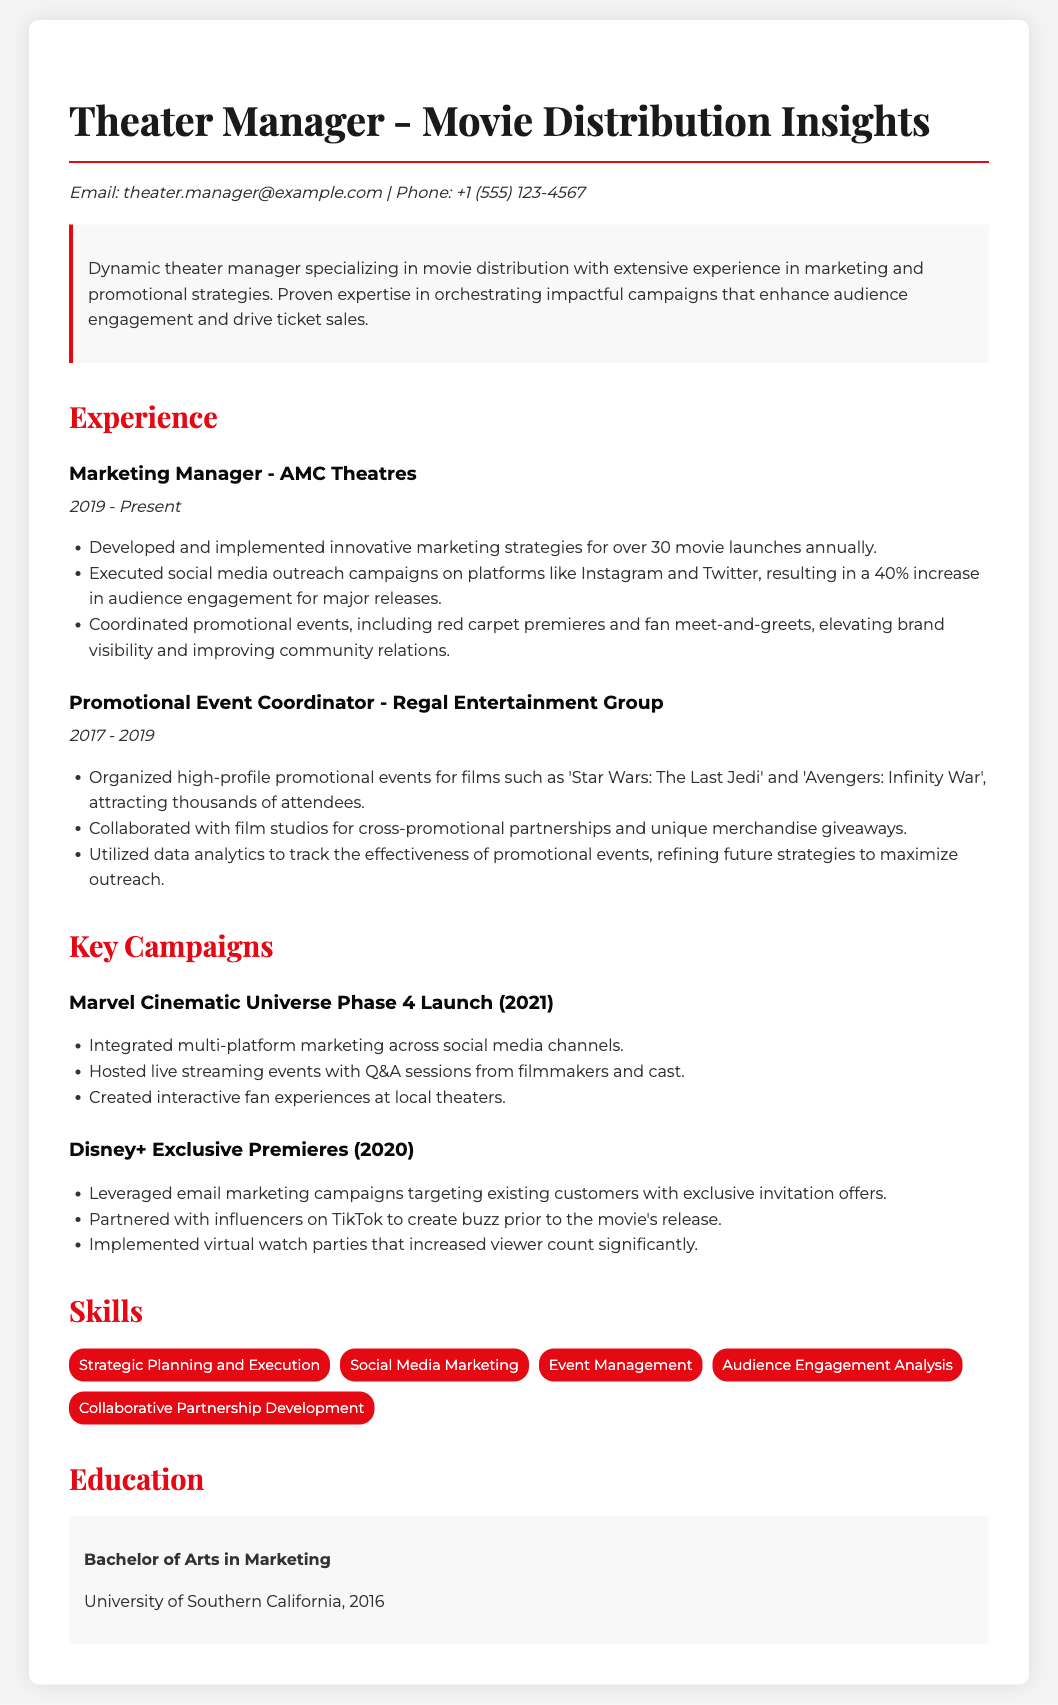what is the job title of the individual? The job title is prominently displayed at the top of the document.
Answer: Theater Manager how many movie launches does the marketing manager oversee annually? This information is mentioned in the experience section of the document.
Answer: over 30 what percentage increase in audience engagement resulted from social media outreach? The document states a specific percentage increase in audience engagement achieved through social media efforts.
Answer: 40% which major movies were organized for promotional events? Specific movies mentioned in the experience section indicate the scope of events coordinated.
Answer: Star Wars: The Last Jedi, Avengers: Infinity War what is the highest level of education attained? The education section lists the degree obtained by the theater manager.
Answer: Bachelor of Arts in Marketing which social media platforms were used for outreach campaigns? The specific platforms utilized for social media outreach campaigns are listed in the document.
Answer: Instagram, Twitter what year did the individual start working at AMC Theatres? The starting year of the employment is clearly stated in the experience timeline.
Answer: 2019 what is one skill listed in the skills section? One of the skills is included in the skills list, displaying expertise areas.
Answer: Strategic Planning and Execution 